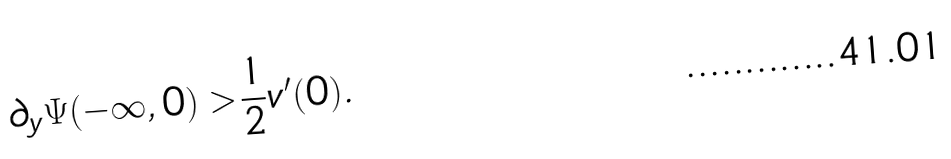Convert formula to latex. <formula><loc_0><loc_0><loc_500><loc_500>\partial _ { y } \Psi ( - \infty , 0 ) > \frac { 1 } { 2 } v ^ { \prime } ( 0 ) .</formula> 